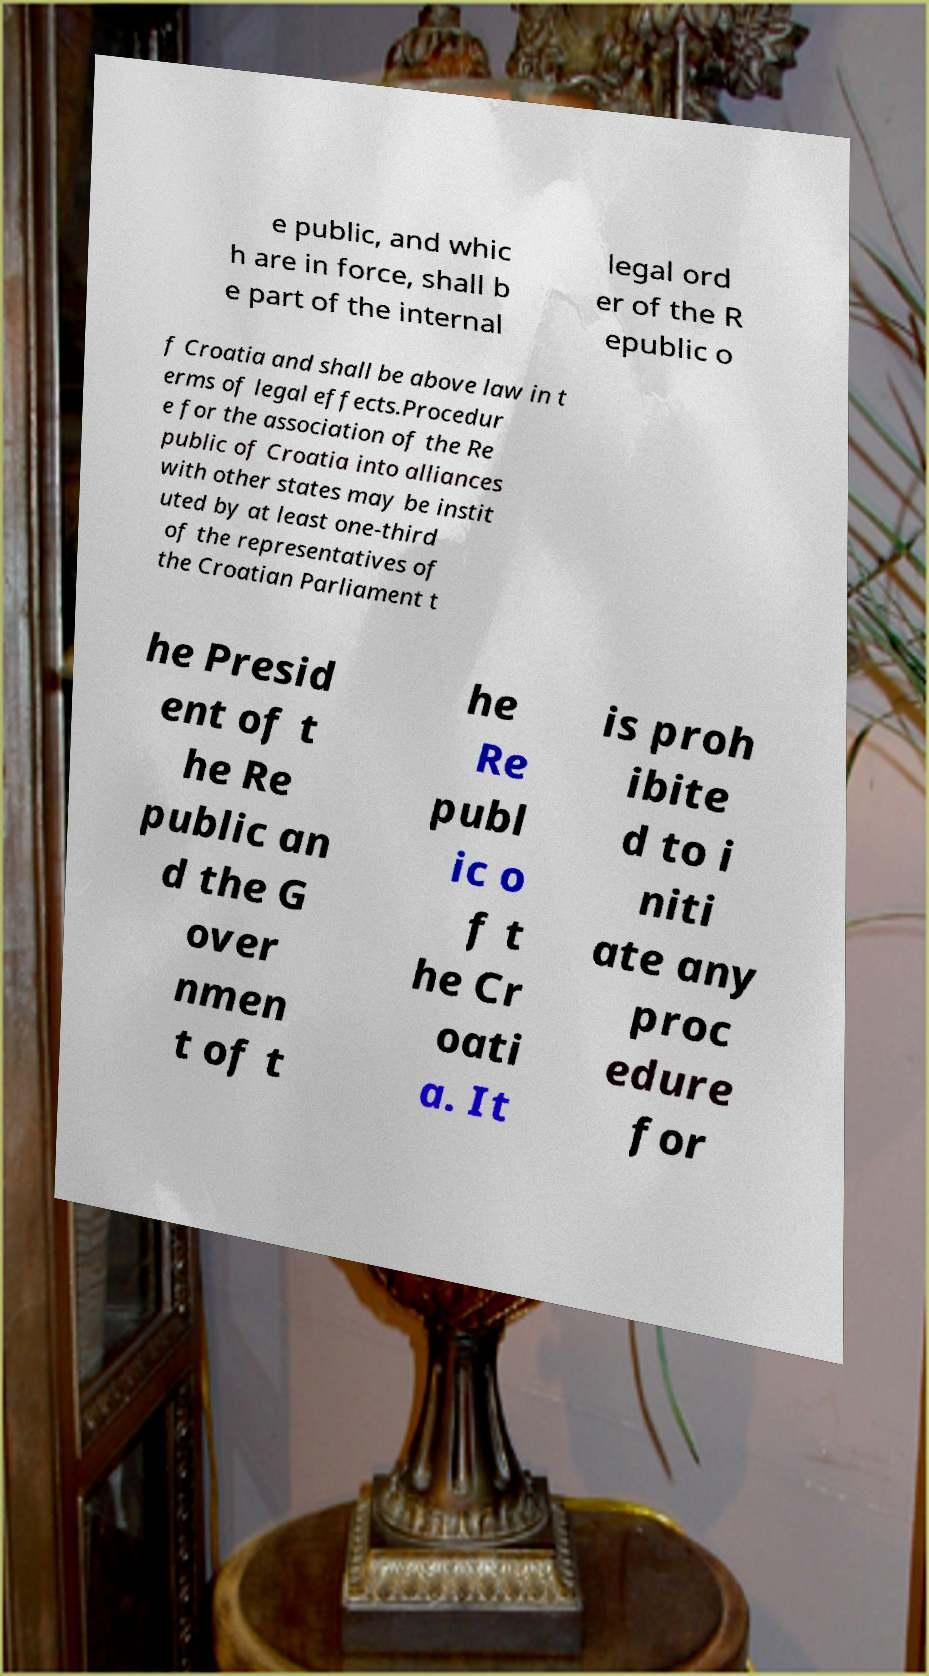Can you accurately transcribe the text from the provided image for me? e public, and whic h are in force, shall b e part of the internal legal ord er of the R epublic o f Croatia and shall be above law in t erms of legal effects.Procedur e for the association of the Re public of Croatia into alliances with other states may be instit uted by at least one-third of the representatives of the Croatian Parliament t he Presid ent of t he Re public an d the G over nmen t of t he Re publ ic o f t he Cr oati a. It is proh ibite d to i niti ate any proc edure for 